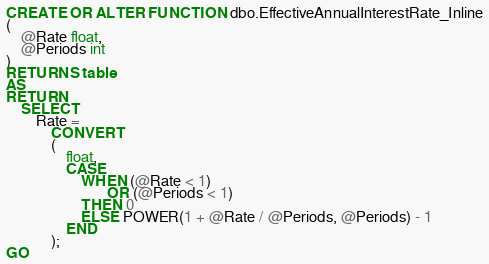Convert code to text. <code><loc_0><loc_0><loc_500><loc_500><_SQL_>CREATE OR ALTER FUNCTION dbo.EffectiveAnnualInterestRate_Inline
(
    @Rate float,
    @Periods int
)
RETURNS table
AS
RETURN
    SELECT
        Rate =
            CONVERT
            (
                float,
                CASE 
                    WHEN (@Rate < 1)
                           OR (@Periods < 1)
                    THEN 0
                    ELSE POWER(1 + @Rate / @Periods, @Periods) - 1
                END
            );
GO</code> 